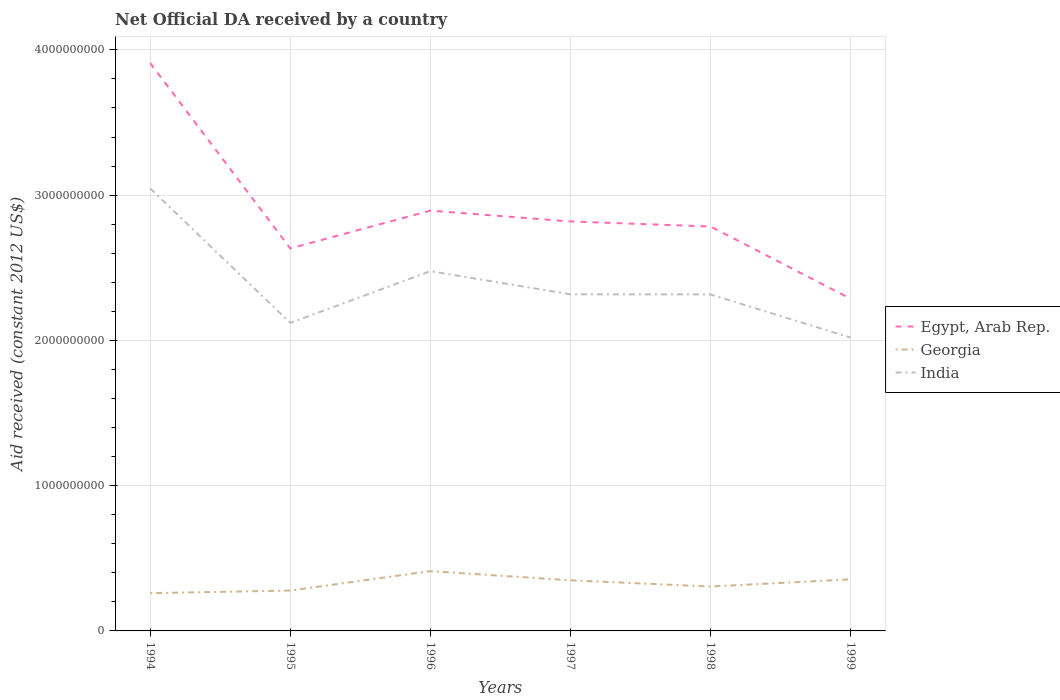Does the line corresponding to India intersect with the line corresponding to Georgia?
Keep it short and to the point. No. Is the number of lines equal to the number of legend labels?
Your response must be concise. Yes. Across all years, what is the maximum net official development assistance aid received in Egypt, Arab Rep.?
Your answer should be compact. 2.29e+09. What is the total net official development assistance aid received in India in the graph?
Keep it short and to the point. 1.59e+08. What is the difference between the highest and the second highest net official development assistance aid received in Georgia?
Provide a short and direct response. 1.52e+08. What is the difference between the highest and the lowest net official development assistance aid received in India?
Your response must be concise. 2. How many lines are there?
Your response must be concise. 3. Does the graph contain any zero values?
Keep it short and to the point. No. Does the graph contain grids?
Your answer should be compact. Yes. Where does the legend appear in the graph?
Keep it short and to the point. Center right. How many legend labels are there?
Your answer should be very brief. 3. What is the title of the graph?
Your response must be concise. Net Official DA received by a country. Does "Middle income" appear as one of the legend labels in the graph?
Offer a terse response. No. What is the label or title of the X-axis?
Offer a very short reply. Years. What is the label or title of the Y-axis?
Keep it short and to the point. Aid received (constant 2012 US$). What is the Aid received (constant 2012 US$) in Egypt, Arab Rep. in 1994?
Provide a short and direct response. 3.91e+09. What is the Aid received (constant 2012 US$) of Georgia in 1994?
Your response must be concise. 2.60e+08. What is the Aid received (constant 2012 US$) in India in 1994?
Provide a short and direct response. 3.05e+09. What is the Aid received (constant 2012 US$) of Egypt, Arab Rep. in 1995?
Your response must be concise. 2.63e+09. What is the Aid received (constant 2012 US$) of Georgia in 1995?
Offer a terse response. 2.78e+08. What is the Aid received (constant 2012 US$) of India in 1995?
Give a very brief answer. 2.12e+09. What is the Aid received (constant 2012 US$) in Egypt, Arab Rep. in 1996?
Ensure brevity in your answer.  2.89e+09. What is the Aid received (constant 2012 US$) of Georgia in 1996?
Provide a succinct answer. 4.12e+08. What is the Aid received (constant 2012 US$) of India in 1996?
Your answer should be very brief. 2.48e+09. What is the Aid received (constant 2012 US$) of Egypt, Arab Rep. in 1997?
Offer a very short reply. 2.82e+09. What is the Aid received (constant 2012 US$) of Georgia in 1997?
Give a very brief answer. 3.49e+08. What is the Aid received (constant 2012 US$) in India in 1997?
Keep it short and to the point. 2.32e+09. What is the Aid received (constant 2012 US$) in Egypt, Arab Rep. in 1998?
Provide a short and direct response. 2.78e+09. What is the Aid received (constant 2012 US$) of Georgia in 1998?
Your answer should be very brief. 3.06e+08. What is the Aid received (constant 2012 US$) of India in 1998?
Keep it short and to the point. 2.32e+09. What is the Aid received (constant 2012 US$) in Egypt, Arab Rep. in 1999?
Provide a succinct answer. 2.29e+09. What is the Aid received (constant 2012 US$) in Georgia in 1999?
Offer a very short reply. 3.55e+08. What is the Aid received (constant 2012 US$) of India in 1999?
Provide a succinct answer. 2.02e+09. Across all years, what is the maximum Aid received (constant 2012 US$) of Egypt, Arab Rep.?
Provide a succinct answer. 3.91e+09. Across all years, what is the maximum Aid received (constant 2012 US$) of Georgia?
Keep it short and to the point. 4.12e+08. Across all years, what is the maximum Aid received (constant 2012 US$) of India?
Give a very brief answer. 3.05e+09. Across all years, what is the minimum Aid received (constant 2012 US$) in Egypt, Arab Rep.?
Make the answer very short. 2.29e+09. Across all years, what is the minimum Aid received (constant 2012 US$) in Georgia?
Provide a succinct answer. 2.60e+08. Across all years, what is the minimum Aid received (constant 2012 US$) of India?
Your response must be concise. 2.02e+09. What is the total Aid received (constant 2012 US$) of Egypt, Arab Rep. in the graph?
Keep it short and to the point. 1.73e+1. What is the total Aid received (constant 2012 US$) in Georgia in the graph?
Offer a very short reply. 1.96e+09. What is the total Aid received (constant 2012 US$) of India in the graph?
Keep it short and to the point. 1.43e+1. What is the difference between the Aid received (constant 2012 US$) in Egypt, Arab Rep. in 1994 and that in 1995?
Offer a terse response. 1.28e+09. What is the difference between the Aid received (constant 2012 US$) in Georgia in 1994 and that in 1995?
Give a very brief answer. -1.80e+07. What is the difference between the Aid received (constant 2012 US$) in India in 1994 and that in 1995?
Provide a succinct answer. 9.26e+08. What is the difference between the Aid received (constant 2012 US$) in Egypt, Arab Rep. in 1994 and that in 1996?
Your answer should be compact. 1.02e+09. What is the difference between the Aid received (constant 2012 US$) in Georgia in 1994 and that in 1996?
Your response must be concise. -1.52e+08. What is the difference between the Aid received (constant 2012 US$) of India in 1994 and that in 1996?
Provide a succinct answer. 5.70e+08. What is the difference between the Aid received (constant 2012 US$) of Egypt, Arab Rep. in 1994 and that in 1997?
Keep it short and to the point. 1.09e+09. What is the difference between the Aid received (constant 2012 US$) of Georgia in 1994 and that in 1997?
Provide a succinct answer. -8.85e+07. What is the difference between the Aid received (constant 2012 US$) in India in 1994 and that in 1997?
Ensure brevity in your answer.  7.29e+08. What is the difference between the Aid received (constant 2012 US$) of Egypt, Arab Rep. in 1994 and that in 1998?
Ensure brevity in your answer.  1.13e+09. What is the difference between the Aid received (constant 2012 US$) in Georgia in 1994 and that in 1998?
Provide a succinct answer. -4.56e+07. What is the difference between the Aid received (constant 2012 US$) in India in 1994 and that in 1998?
Offer a terse response. 7.30e+08. What is the difference between the Aid received (constant 2012 US$) in Egypt, Arab Rep. in 1994 and that in 1999?
Make the answer very short. 1.62e+09. What is the difference between the Aid received (constant 2012 US$) of Georgia in 1994 and that in 1999?
Offer a very short reply. -9.49e+07. What is the difference between the Aid received (constant 2012 US$) of India in 1994 and that in 1999?
Provide a succinct answer. 1.03e+09. What is the difference between the Aid received (constant 2012 US$) in Egypt, Arab Rep. in 1995 and that in 1996?
Ensure brevity in your answer.  -2.60e+08. What is the difference between the Aid received (constant 2012 US$) in Georgia in 1995 and that in 1996?
Your answer should be very brief. -1.34e+08. What is the difference between the Aid received (constant 2012 US$) in India in 1995 and that in 1996?
Offer a very short reply. -3.56e+08. What is the difference between the Aid received (constant 2012 US$) in Egypt, Arab Rep. in 1995 and that in 1997?
Your answer should be very brief. -1.86e+08. What is the difference between the Aid received (constant 2012 US$) of Georgia in 1995 and that in 1997?
Your response must be concise. -7.05e+07. What is the difference between the Aid received (constant 2012 US$) in India in 1995 and that in 1997?
Provide a short and direct response. -1.97e+08. What is the difference between the Aid received (constant 2012 US$) of Egypt, Arab Rep. in 1995 and that in 1998?
Make the answer very short. -1.51e+08. What is the difference between the Aid received (constant 2012 US$) in Georgia in 1995 and that in 1998?
Provide a succinct answer. -2.76e+07. What is the difference between the Aid received (constant 2012 US$) of India in 1995 and that in 1998?
Ensure brevity in your answer.  -1.96e+08. What is the difference between the Aid received (constant 2012 US$) of Egypt, Arab Rep. in 1995 and that in 1999?
Give a very brief answer. 3.46e+08. What is the difference between the Aid received (constant 2012 US$) of Georgia in 1995 and that in 1999?
Provide a short and direct response. -7.69e+07. What is the difference between the Aid received (constant 2012 US$) in India in 1995 and that in 1999?
Make the answer very short. 1.01e+08. What is the difference between the Aid received (constant 2012 US$) in Egypt, Arab Rep. in 1996 and that in 1997?
Your answer should be very brief. 7.45e+07. What is the difference between the Aid received (constant 2012 US$) in Georgia in 1996 and that in 1997?
Your answer should be very brief. 6.32e+07. What is the difference between the Aid received (constant 2012 US$) of India in 1996 and that in 1997?
Give a very brief answer. 1.59e+08. What is the difference between the Aid received (constant 2012 US$) in Egypt, Arab Rep. in 1996 and that in 1998?
Provide a short and direct response. 1.09e+08. What is the difference between the Aid received (constant 2012 US$) in Georgia in 1996 and that in 1998?
Your answer should be very brief. 1.06e+08. What is the difference between the Aid received (constant 2012 US$) in India in 1996 and that in 1998?
Your response must be concise. 1.60e+08. What is the difference between the Aid received (constant 2012 US$) of Egypt, Arab Rep. in 1996 and that in 1999?
Your response must be concise. 6.06e+08. What is the difference between the Aid received (constant 2012 US$) in Georgia in 1996 and that in 1999?
Your response must be concise. 5.68e+07. What is the difference between the Aid received (constant 2012 US$) of India in 1996 and that in 1999?
Ensure brevity in your answer.  4.57e+08. What is the difference between the Aid received (constant 2012 US$) of Egypt, Arab Rep. in 1997 and that in 1998?
Your answer should be compact. 3.49e+07. What is the difference between the Aid received (constant 2012 US$) in Georgia in 1997 and that in 1998?
Provide a short and direct response. 4.29e+07. What is the difference between the Aid received (constant 2012 US$) of India in 1997 and that in 1998?
Offer a very short reply. 9.00e+05. What is the difference between the Aid received (constant 2012 US$) of Egypt, Arab Rep. in 1997 and that in 1999?
Keep it short and to the point. 5.32e+08. What is the difference between the Aid received (constant 2012 US$) in Georgia in 1997 and that in 1999?
Offer a terse response. -6.39e+06. What is the difference between the Aid received (constant 2012 US$) in India in 1997 and that in 1999?
Your response must be concise. 2.98e+08. What is the difference between the Aid received (constant 2012 US$) of Egypt, Arab Rep. in 1998 and that in 1999?
Your answer should be very brief. 4.97e+08. What is the difference between the Aid received (constant 2012 US$) of Georgia in 1998 and that in 1999?
Offer a terse response. -4.93e+07. What is the difference between the Aid received (constant 2012 US$) in India in 1998 and that in 1999?
Provide a short and direct response. 2.97e+08. What is the difference between the Aid received (constant 2012 US$) in Egypt, Arab Rep. in 1994 and the Aid received (constant 2012 US$) in Georgia in 1995?
Give a very brief answer. 3.63e+09. What is the difference between the Aid received (constant 2012 US$) of Egypt, Arab Rep. in 1994 and the Aid received (constant 2012 US$) of India in 1995?
Give a very brief answer. 1.79e+09. What is the difference between the Aid received (constant 2012 US$) in Georgia in 1994 and the Aid received (constant 2012 US$) in India in 1995?
Provide a succinct answer. -1.86e+09. What is the difference between the Aid received (constant 2012 US$) of Egypt, Arab Rep. in 1994 and the Aid received (constant 2012 US$) of Georgia in 1996?
Make the answer very short. 3.50e+09. What is the difference between the Aid received (constant 2012 US$) of Egypt, Arab Rep. in 1994 and the Aid received (constant 2012 US$) of India in 1996?
Ensure brevity in your answer.  1.43e+09. What is the difference between the Aid received (constant 2012 US$) in Georgia in 1994 and the Aid received (constant 2012 US$) in India in 1996?
Offer a terse response. -2.22e+09. What is the difference between the Aid received (constant 2012 US$) of Egypt, Arab Rep. in 1994 and the Aid received (constant 2012 US$) of Georgia in 1997?
Give a very brief answer. 3.56e+09. What is the difference between the Aid received (constant 2012 US$) in Egypt, Arab Rep. in 1994 and the Aid received (constant 2012 US$) in India in 1997?
Ensure brevity in your answer.  1.59e+09. What is the difference between the Aid received (constant 2012 US$) in Georgia in 1994 and the Aid received (constant 2012 US$) in India in 1997?
Provide a succinct answer. -2.06e+09. What is the difference between the Aid received (constant 2012 US$) of Egypt, Arab Rep. in 1994 and the Aid received (constant 2012 US$) of Georgia in 1998?
Give a very brief answer. 3.60e+09. What is the difference between the Aid received (constant 2012 US$) of Egypt, Arab Rep. in 1994 and the Aid received (constant 2012 US$) of India in 1998?
Ensure brevity in your answer.  1.59e+09. What is the difference between the Aid received (constant 2012 US$) in Georgia in 1994 and the Aid received (constant 2012 US$) in India in 1998?
Provide a short and direct response. -2.06e+09. What is the difference between the Aid received (constant 2012 US$) of Egypt, Arab Rep. in 1994 and the Aid received (constant 2012 US$) of Georgia in 1999?
Offer a very short reply. 3.55e+09. What is the difference between the Aid received (constant 2012 US$) of Egypt, Arab Rep. in 1994 and the Aid received (constant 2012 US$) of India in 1999?
Provide a short and direct response. 1.89e+09. What is the difference between the Aid received (constant 2012 US$) of Georgia in 1994 and the Aid received (constant 2012 US$) of India in 1999?
Give a very brief answer. -1.76e+09. What is the difference between the Aid received (constant 2012 US$) of Egypt, Arab Rep. in 1995 and the Aid received (constant 2012 US$) of Georgia in 1996?
Provide a succinct answer. 2.22e+09. What is the difference between the Aid received (constant 2012 US$) of Egypt, Arab Rep. in 1995 and the Aid received (constant 2012 US$) of India in 1996?
Ensure brevity in your answer.  1.57e+08. What is the difference between the Aid received (constant 2012 US$) of Georgia in 1995 and the Aid received (constant 2012 US$) of India in 1996?
Offer a very short reply. -2.20e+09. What is the difference between the Aid received (constant 2012 US$) of Egypt, Arab Rep. in 1995 and the Aid received (constant 2012 US$) of Georgia in 1997?
Make the answer very short. 2.28e+09. What is the difference between the Aid received (constant 2012 US$) in Egypt, Arab Rep. in 1995 and the Aid received (constant 2012 US$) in India in 1997?
Keep it short and to the point. 3.16e+08. What is the difference between the Aid received (constant 2012 US$) of Georgia in 1995 and the Aid received (constant 2012 US$) of India in 1997?
Provide a succinct answer. -2.04e+09. What is the difference between the Aid received (constant 2012 US$) in Egypt, Arab Rep. in 1995 and the Aid received (constant 2012 US$) in Georgia in 1998?
Offer a terse response. 2.33e+09. What is the difference between the Aid received (constant 2012 US$) of Egypt, Arab Rep. in 1995 and the Aid received (constant 2012 US$) of India in 1998?
Make the answer very short. 3.17e+08. What is the difference between the Aid received (constant 2012 US$) in Georgia in 1995 and the Aid received (constant 2012 US$) in India in 1998?
Provide a short and direct response. -2.04e+09. What is the difference between the Aid received (constant 2012 US$) of Egypt, Arab Rep. in 1995 and the Aid received (constant 2012 US$) of Georgia in 1999?
Your answer should be compact. 2.28e+09. What is the difference between the Aid received (constant 2012 US$) of Egypt, Arab Rep. in 1995 and the Aid received (constant 2012 US$) of India in 1999?
Provide a succinct answer. 6.14e+08. What is the difference between the Aid received (constant 2012 US$) of Georgia in 1995 and the Aid received (constant 2012 US$) of India in 1999?
Give a very brief answer. -1.74e+09. What is the difference between the Aid received (constant 2012 US$) of Egypt, Arab Rep. in 1996 and the Aid received (constant 2012 US$) of Georgia in 1997?
Give a very brief answer. 2.54e+09. What is the difference between the Aid received (constant 2012 US$) of Egypt, Arab Rep. in 1996 and the Aid received (constant 2012 US$) of India in 1997?
Provide a short and direct response. 5.76e+08. What is the difference between the Aid received (constant 2012 US$) of Georgia in 1996 and the Aid received (constant 2012 US$) of India in 1997?
Your response must be concise. -1.91e+09. What is the difference between the Aid received (constant 2012 US$) in Egypt, Arab Rep. in 1996 and the Aid received (constant 2012 US$) in Georgia in 1998?
Provide a short and direct response. 2.59e+09. What is the difference between the Aid received (constant 2012 US$) of Egypt, Arab Rep. in 1996 and the Aid received (constant 2012 US$) of India in 1998?
Ensure brevity in your answer.  5.77e+08. What is the difference between the Aid received (constant 2012 US$) of Georgia in 1996 and the Aid received (constant 2012 US$) of India in 1998?
Ensure brevity in your answer.  -1.90e+09. What is the difference between the Aid received (constant 2012 US$) in Egypt, Arab Rep. in 1996 and the Aid received (constant 2012 US$) in Georgia in 1999?
Offer a terse response. 2.54e+09. What is the difference between the Aid received (constant 2012 US$) in Egypt, Arab Rep. in 1996 and the Aid received (constant 2012 US$) in India in 1999?
Keep it short and to the point. 8.74e+08. What is the difference between the Aid received (constant 2012 US$) in Georgia in 1996 and the Aid received (constant 2012 US$) in India in 1999?
Offer a terse response. -1.61e+09. What is the difference between the Aid received (constant 2012 US$) of Egypt, Arab Rep. in 1997 and the Aid received (constant 2012 US$) of Georgia in 1998?
Offer a terse response. 2.51e+09. What is the difference between the Aid received (constant 2012 US$) in Egypt, Arab Rep. in 1997 and the Aid received (constant 2012 US$) in India in 1998?
Your answer should be very brief. 5.02e+08. What is the difference between the Aid received (constant 2012 US$) in Georgia in 1997 and the Aid received (constant 2012 US$) in India in 1998?
Offer a terse response. -1.97e+09. What is the difference between the Aid received (constant 2012 US$) of Egypt, Arab Rep. in 1997 and the Aid received (constant 2012 US$) of Georgia in 1999?
Offer a very short reply. 2.46e+09. What is the difference between the Aid received (constant 2012 US$) in Egypt, Arab Rep. in 1997 and the Aid received (constant 2012 US$) in India in 1999?
Offer a very short reply. 7.99e+08. What is the difference between the Aid received (constant 2012 US$) of Georgia in 1997 and the Aid received (constant 2012 US$) of India in 1999?
Your answer should be compact. -1.67e+09. What is the difference between the Aid received (constant 2012 US$) in Egypt, Arab Rep. in 1998 and the Aid received (constant 2012 US$) in Georgia in 1999?
Your response must be concise. 2.43e+09. What is the difference between the Aid received (constant 2012 US$) in Egypt, Arab Rep. in 1998 and the Aid received (constant 2012 US$) in India in 1999?
Your response must be concise. 7.65e+08. What is the difference between the Aid received (constant 2012 US$) in Georgia in 1998 and the Aid received (constant 2012 US$) in India in 1999?
Provide a succinct answer. -1.71e+09. What is the average Aid received (constant 2012 US$) of Egypt, Arab Rep. per year?
Ensure brevity in your answer.  2.89e+09. What is the average Aid received (constant 2012 US$) in Georgia per year?
Your answer should be very brief. 3.26e+08. What is the average Aid received (constant 2012 US$) in India per year?
Keep it short and to the point. 2.38e+09. In the year 1994, what is the difference between the Aid received (constant 2012 US$) in Egypt, Arab Rep. and Aid received (constant 2012 US$) in Georgia?
Your answer should be compact. 3.65e+09. In the year 1994, what is the difference between the Aid received (constant 2012 US$) in Egypt, Arab Rep. and Aid received (constant 2012 US$) in India?
Your response must be concise. 8.63e+08. In the year 1994, what is the difference between the Aid received (constant 2012 US$) of Georgia and Aid received (constant 2012 US$) of India?
Your answer should be compact. -2.79e+09. In the year 1995, what is the difference between the Aid received (constant 2012 US$) in Egypt, Arab Rep. and Aid received (constant 2012 US$) in Georgia?
Provide a short and direct response. 2.36e+09. In the year 1995, what is the difference between the Aid received (constant 2012 US$) of Egypt, Arab Rep. and Aid received (constant 2012 US$) of India?
Your answer should be very brief. 5.13e+08. In the year 1995, what is the difference between the Aid received (constant 2012 US$) in Georgia and Aid received (constant 2012 US$) in India?
Give a very brief answer. -1.84e+09. In the year 1996, what is the difference between the Aid received (constant 2012 US$) of Egypt, Arab Rep. and Aid received (constant 2012 US$) of Georgia?
Your response must be concise. 2.48e+09. In the year 1996, what is the difference between the Aid received (constant 2012 US$) of Egypt, Arab Rep. and Aid received (constant 2012 US$) of India?
Ensure brevity in your answer.  4.17e+08. In the year 1996, what is the difference between the Aid received (constant 2012 US$) of Georgia and Aid received (constant 2012 US$) of India?
Give a very brief answer. -2.06e+09. In the year 1997, what is the difference between the Aid received (constant 2012 US$) in Egypt, Arab Rep. and Aid received (constant 2012 US$) in Georgia?
Keep it short and to the point. 2.47e+09. In the year 1997, what is the difference between the Aid received (constant 2012 US$) in Egypt, Arab Rep. and Aid received (constant 2012 US$) in India?
Your answer should be compact. 5.02e+08. In the year 1997, what is the difference between the Aid received (constant 2012 US$) of Georgia and Aid received (constant 2012 US$) of India?
Offer a very short reply. -1.97e+09. In the year 1998, what is the difference between the Aid received (constant 2012 US$) in Egypt, Arab Rep. and Aid received (constant 2012 US$) in Georgia?
Your answer should be compact. 2.48e+09. In the year 1998, what is the difference between the Aid received (constant 2012 US$) of Egypt, Arab Rep. and Aid received (constant 2012 US$) of India?
Provide a succinct answer. 4.68e+08. In the year 1998, what is the difference between the Aid received (constant 2012 US$) in Georgia and Aid received (constant 2012 US$) in India?
Ensure brevity in your answer.  -2.01e+09. In the year 1999, what is the difference between the Aid received (constant 2012 US$) of Egypt, Arab Rep. and Aid received (constant 2012 US$) of Georgia?
Provide a short and direct response. 1.93e+09. In the year 1999, what is the difference between the Aid received (constant 2012 US$) in Egypt, Arab Rep. and Aid received (constant 2012 US$) in India?
Give a very brief answer. 2.68e+08. In the year 1999, what is the difference between the Aid received (constant 2012 US$) of Georgia and Aid received (constant 2012 US$) of India?
Provide a succinct answer. -1.66e+09. What is the ratio of the Aid received (constant 2012 US$) in Egypt, Arab Rep. in 1994 to that in 1995?
Provide a succinct answer. 1.48. What is the ratio of the Aid received (constant 2012 US$) of Georgia in 1994 to that in 1995?
Your answer should be very brief. 0.94. What is the ratio of the Aid received (constant 2012 US$) in India in 1994 to that in 1995?
Offer a very short reply. 1.44. What is the ratio of the Aid received (constant 2012 US$) of Egypt, Arab Rep. in 1994 to that in 1996?
Your answer should be compact. 1.35. What is the ratio of the Aid received (constant 2012 US$) in Georgia in 1994 to that in 1996?
Your answer should be very brief. 0.63. What is the ratio of the Aid received (constant 2012 US$) in India in 1994 to that in 1996?
Offer a terse response. 1.23. What is the ratio of the Aid received (constant 2012 US$) of Egypt, Arab Rep. in 1994 to that in 1997?
Offer a very short reply. 1.39. What is the ratio of the Aid received (constant 2012 US$) of Georgia in 1994 to that in 1997?
Provide a short and direct response. 0.75. What is the ratio of the Aid received (constant 2012 US$) of India in 1994 to that in 1997?
Ensure brevity in your answer.  1.31. What is the ratio of the Aid received (constant 2012 US$) of Egypt, Arab Rep. in 1994 to that in 1998?
Provide a succinct answer. 1.4. What is the ratio of the Aid received (constant 2012 US$) in Georgia in 1994 to that in 1998?
Provide a short and direct response. 0.85. What is the ratio of the Aid received (constant 2012 US$) of India in 1994 to that in 1998?
Your answer should be very brief. 1.32. What is the ratio of the Aid received (constant 2012 US$) of Egypt, Arab Rep. in 1994 to that in 1999?
Provide a short and direct response. 1.71. What is the ratio of the Aid received (constant 2012 US$) of Georgia in 1994 to that in 1999?
Keep it short and to the point. 0.73. What is the ratio of the Aid received (constant 2012 US$) of India in 1994 to that in 1999?
Keep it short and to the point. 1.51. What is the ratio of the Aid received (constant 2012 US$) of Egypt, Arab Rep. in 1995 to that in 1996?
Provide a short and direct response. 0.91. What is the ratio of the Aid received (constant 2012 US$) in Georgia in 1995 to that in 1996?
Offer a very short reply. 0.68. What is the ratio of the Aid received (constant 2012 US$) of India in 1995 to that in 1996?
Your answer should be very brief. 0.86. What is the ratio of the Aid received (constant 2012 US$) in Egypt, Arab Rep. in 1995 to that in 1997?
Your answer should be compact. 0.93. What is the ratio of the Aid received (constant 2012 US$) of Georgia in 1995 to that in 1997?
Your answer should be very brief. 0.8. What is the ratio of the Aid received (constant 2012 US$) of India in 1995 to that in 1997?
Your response must be concise. 0.92. What is the ratio of the Aid received (constant 2012 US$) in Egypt, Arab Rep. in 1995 to that in 1998?
Give a very brief answer. 0.95. What is the ratio of the Aid received (constant 2012 US$) of Georgia in 1995 to that in 1998?
Your answer should be compact. 0.91. What is the ratio of the Aid received (constant 2012 US$) in India in 1995 to that in 1998?
Provide a succinct answer. 0.92. What is the ratio of the Aid received (constant 2012 US$) of Egypt, Arab Rep. in 1995 to that in 1999?
Your answer should be very brief. 1.15. What is the ratio of the Aid received (constant 2012 US$) in Georgia in 1995 to that in 1999?
Provide a short and direct response. 0.78. What is the ratio of the Aid received (constant 2012 US$) of India in 1995 to that in 1999?
Give a very brief answer. 1.05. What is the ratio of the Aid received (constant 2012 US$) in Egypt, Arab Rep. in 1996 to that in 1997?
Ensure brevity in your answer.  1.03. What is the ratio of the Aid received (constant 2012 US$) of Georgia in 1996 to that in 1997?
Your response must be concise. 1.18. What is the ratio of the Aid received (constant 2012 US$) in India in 1996 to that in 1997?
Give a very brief answer. 1.07. What is the ratio of the Aid received (constant 2012 US$) in Egypt, Arab Rep. in 1996 to that in 1998?
Make the answer very short. 1.04. What is the ratio of the Aid received (constant 2012 US$) in Georgia in 1996 to that in 1998?
Your answer should be compact. 1.35. What is the ratio of the Aid received (constant 2012 US$) in India in 1996 to that in 1998?
Offer a very short reply. 1.07. What is the ratio of the Aid received (constant 2012 US$) in Egypt, Arab Rep. in 1996 to that in 1999?
Offer a terse response. 1.26. What is the ratio of the Aid received (constant 2012 US$) in Georgia in 1996 to that in 1999?
Your response must be concise. 1.16. What is the ratio of the Aid received (constant 2012 US$) of India in 1996 to that in 1999?
Provide a short and direct response. 1.23. What is the ratio of the Aid received (constant 2012 US$) of Egypt, Arab Rep. in 1997 to that in 1998?
Your answer should be very brief. 1.01. What is the ratio of the Aid received (constant 2012 US$) in Georgia in 1997 to that in 1998?
Provide a short and direct response. 1.14. What is the ratio of the Aid received (constant 2012 US$) of Egypt, Arab Rep. in 1997 to that in 1999?
Ensure brevity in your answer.  1.23. What is the ratio of the Aid received (constant 2012 US$) of India in 1997 to that in 1999?
Give a very brief answer. 1.15. What is the ratio of the Aid received (constant 2012 US$) of Egypt, Arab Rep. in 1998 to that in 1999?
Your answer should be compact. 1.22. What is the ratio of the Aid received (constant 2012 US$) of Georgia in 1998 to that in 1999?
Provide a short and direct response. 0.86. What is the ratio of the Aid received (constant 2012 US$) in India in 1998 to that in 1999?
Give a very brief answer. 1.15. What is the difference between the highest and the second highest Aid received (constant 2012 US$) in Egypt, Arab Rep.?
Make the answer very short. 1.02e+09. What is the difference between the highest and the second highest Aid received (constant 2012 US$) of Georgia?
Provide a short and direct response. 5.68e+07. What is the difference between the highest and the second highest Aid received (constant 2012 US$) of India?
Your answer should be compact. 5.70e+08. What is the difference between the highest and the lowest Aid received (constant 2012 US$) in Egypt, Arab Rep.?
Ensure brevity in your answer.  1.62e+09. What is the difference between the highest and the lowest Aid received (constant 2012 US$) of Georgia?
Offer a very short reply. 1.52e+08. What is the difference between the highest and the lowest Aid received (constant 2012 US$) of India?
Provide a succinct answer. 1.03e+09. 